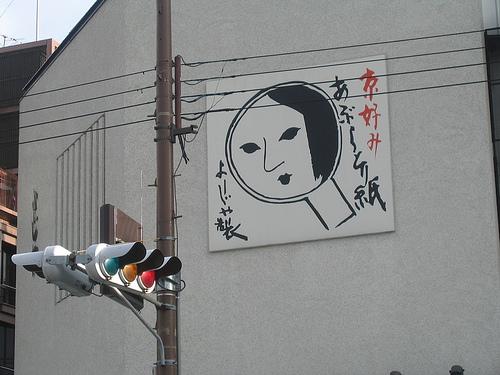Is there grass in this photo?
Answer briefly. No. What is the sign a picture of?
Write a very short answer. Woman. What country was this photo taken in?
Concise answer only. China. What colors is the sign on the wall?
Be succinct. White. What colors are the lights?
Answer briefly. Red yellow green. 